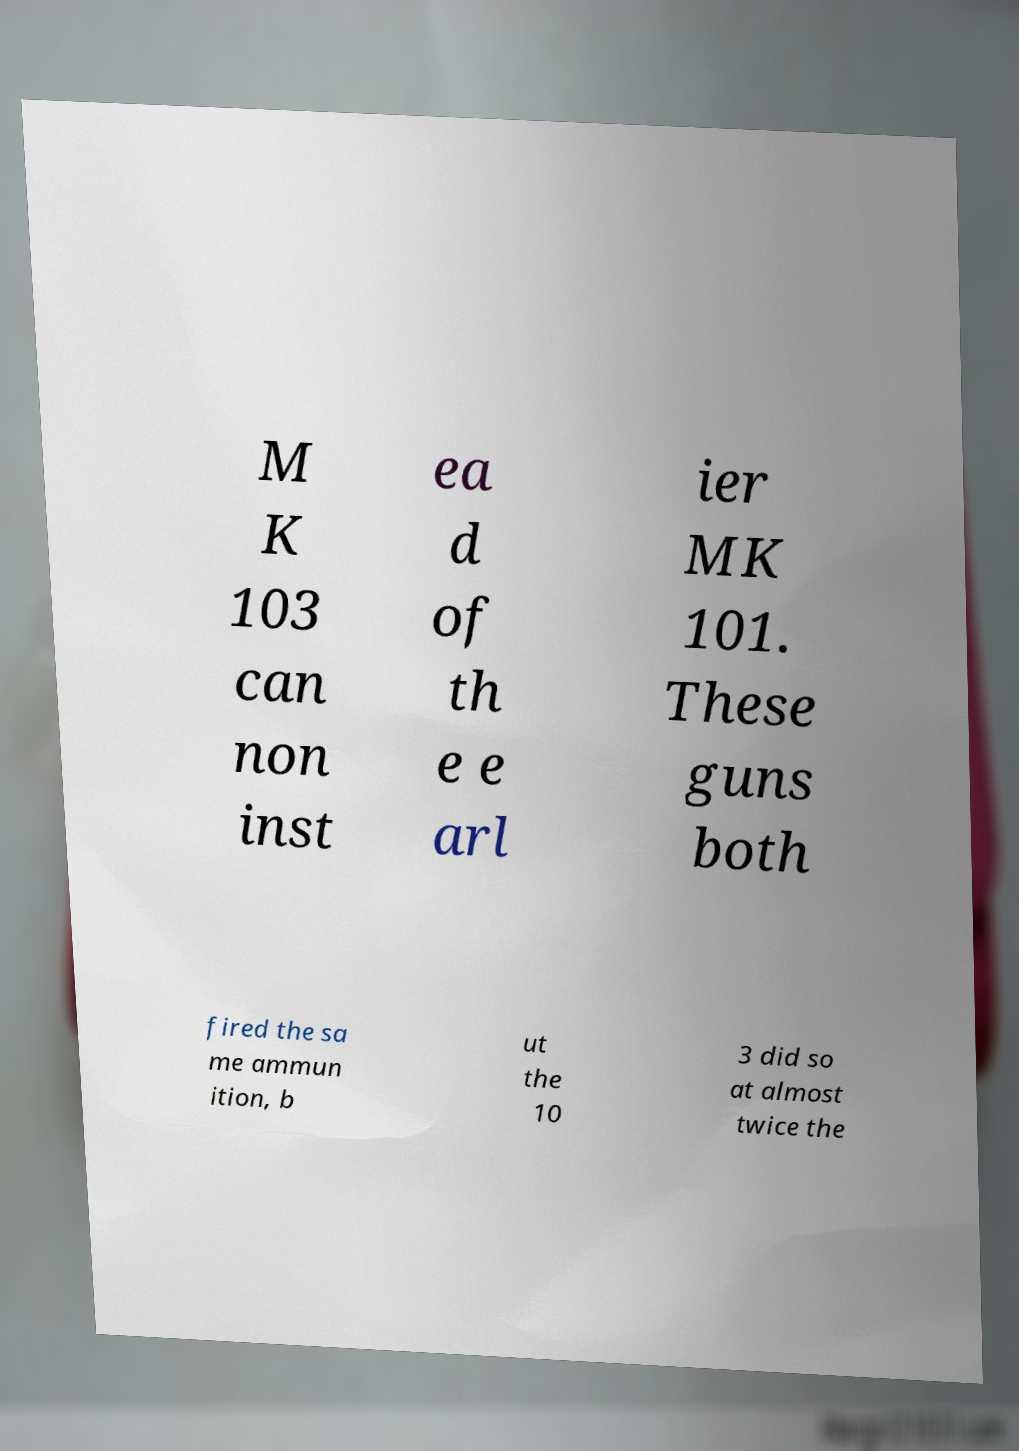Could you assist in decoding the text presented in this image and type it out clearly? M K 103 can non inst ea d of th e e arl ier MK 101. These guns both fired the sa me ammun ition, b ut the 10 3 did so at almost twice the 